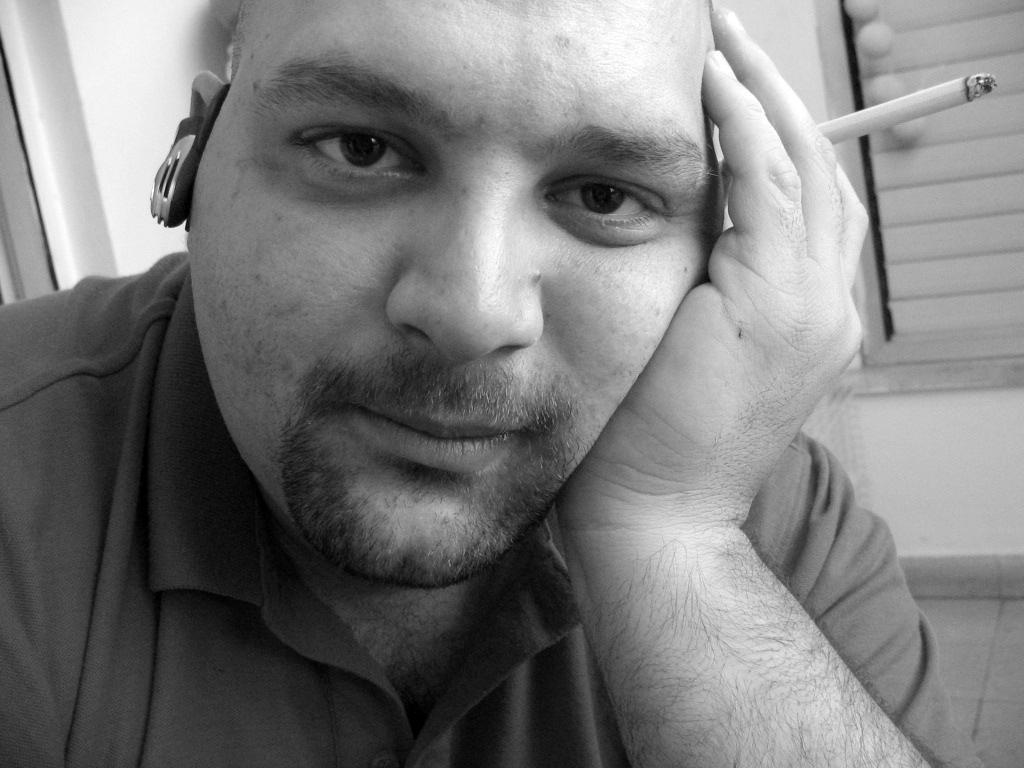Can you describe this image briefly? This picture shows a man seated and holding a cigarette in his hand and we see a window on the side. 